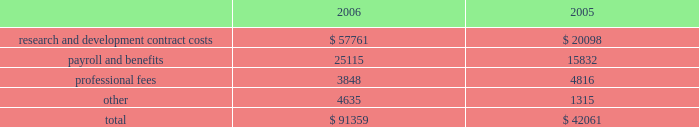Vertex pharmaceuticals incorporated notes to consolidated financial statements ( continued ) i .
Altus investment ( continued ) of the offering , held 450000 shares of redeemable preferred stock , which are not convertible into common stock and which are redeemable for $ 10.00 per share plus annual dividends of $ 0.50 per share , which have been accruing since the redeemable preferred stock was issued in 1999 , at vertex 2019s option on or after december 31 , 2010 , or by altus at any time .
The company was restricted from trading altus securities for a period of six months following the initial public offering .
When the altus securities trading restrictions expired , the company sold the 817749 shares of altus common stock for approximately $ 11.7 million , resulting in a realized gain of approximately $ 7.7 million in august 2006 .
Additionally when the restrictions expired , the company began accounting for the altus warrants as derivative instruments under the financial accounting standards board statement no .
Fas 133 , 201caccounting for derivative instruments and hedging activities 201d ( 201cfas 133 201d ) .
In accordance with fas 133 , in the third quarter of 2006 , the company recorded the altus warrants on its consolidated balance sheet at a fair market value of $ 19.1 million and recorded an unrealized gain on the fair market value of the altus warrants of $ 4.3 million .
In the fourth quarter of 2006 the company sold the altus warrants for approximately $ 18.3 million , resulting in a realized loss of $ 0.7 million .
As a result of the company 2019s sales of altus common stock and altus warrrants in 2006 , the company recorded a realized gain on a sale of investment of $ 11.2 million .
In accordance with the company 2019s policy , as outlined in note b , 201caccounting policies , 201d the company assessed its investment in altus , which it accounts for using the cost method , and determined that there had not been any adjustments to the fair values of that investment that would require the company to write down the investment basis of the asset , in 2005 and 2006 .
The company 2019s cost basis carrying value in its outstanding equity and warrants of altus was $ 18.9 million at december 31 , 2005 .
Accrued expenses and other current liabilities accrued expenses and other current liabilities consist of the following at december 31 ( in thousands ) : k .
Commitments the company leases its facilities and certain equipment under non-cancelable operating leases .
The company 2019s leases have terms through april 2018 .
The term of the kendall square lease began january 1 , 2003 and lease payments commenced in may 2003 .
The company had an obligation under the kendall square lease , staged through 2006 , to build-out the space into finished laboratory and office space .
This lease will expire in 2018 , and the company has the option to extend the term for two consecutive terms of ten years each , ultimately expiring in 2038 .
The company occupies and uses for its operations approximately 120000 square feet of the kendall square facility .
The company has sublease arrangements in place for the remaining rentable square footage of the kendall square facility , with initial terms that expires in april 2011 and august 2012 .
See note e , 201crestructuring 201d for further information. .
Research and development contract costs $ 57761 $ 20098 payroll and benefits 25115 15832 professional fees 3848 4816 4635 1315 $ 91359 $ 42061 .
What is the percent change in research and development contract costs between 2005 and 2006? 
Computations: ((57761 - 20098) / 20098)
Answer: 1.87397. 